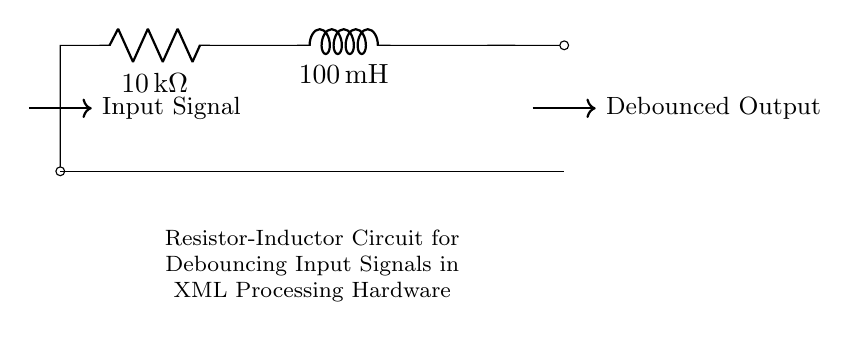What is the resistance in the circuit? The resistance is indicated next to the resistor component labeled "R" in the circuit diagram. It specifies a value of 10kΩ.
Answer: 10kΩ What is the inductance value in the circuit? The inductance is shown next to the inductor component labeled "L." It shows a value of 100mH.
Answer: 100mH How many components are in the circuit? The circuit diagram includes two components: one resistor and one inductor, which you can count by visually inspecting the labeled parts.
Answer: 2 What is the purpose of the resistor-inductor combination? The combination of a resistor and an inductor in this circuit is used for debouncing input signals, which is critical for stabilizing electrical signals before processing. It utilizes the properties of both components to filter out noise.
Answer: Debouncing What type of circuit is depicted? Looking at the components, their configuration and the purpose stated, it is confirmed to be a resistor-inductor circuit specifically intended for input signal debouncing.
Answer: Resistor-Inductor How does the circuit improve signal quality? The parallel arrangement of the resistor and inductor helps in smoothing out fluctuations in the signal, allowing it to filter out noise effectively, thus improving the quality of the signal that's fed into the processing hardware.
Answer: By filtering noise 